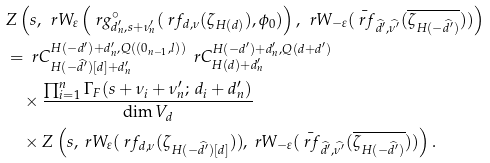<formula> <loc_0><loc_0><loc_500><loc_500>& Z \left ( s , \, \ r W _ { \varepsilon } \left ( \ r g ^ { \circ } _ { d _ { n } ^ { \prime } , s + \nu _ { n } ^ { \prime } } ( \ r f _ { d , \nu } ( \zeta _ { H ( d ) } ) , \phi _ { 0 } ) \right ) , \, \ r W _ { - \varepsilon } ( \bar { \ r f } _ { \widehat { d ^ { \prime } } , \widehat { \nu ^ { \prime } } } ( \overline { \zeta _ { H ( - \widehat { d ^ { \prime } } ) } } ) ) \right ) \\ & = { \ r C ^ { H ( - d ^ { \prime } ) + d _ { n } ^ { \prime } , Q ( ( 0 _ { n - 1 } , l ) ) } _ { H ( - \widehat { d ^ { \prime } } ) [ d ] + d _ { n } ^ { \prime } } } \, \ r C ^ { H ( - d ^ { \prime } ) + d _ { n } ^ { \prime } , Q ( d + d ^ { \prime } ) } _ { H ( d ) + d _ { n } ^ { \prime } } \\ & \quad \times \frac { \prod _ { i = 1 } ^ { n } \Gamma _ { F } ( s + \nu _ { i } + \nu _ { n } ^ { \prime } ; \, d _ { i } + d _ { n } ^ { \prime } ) } { \dim V _ { d } } \\ & \quad \times Z \left ( s , \ r W _ { \varepsilon } ( \ r f _ { d , \nu } ( \zeta _ { H ( - \widehat { d ^ { \prime } } ) [ d ] } ) ) , \ r W _ { - \varepsilon } ( \bar { \ r f } _ { \widehat { d ^ { \prime } } , \widehat { \nu ^ { \prime } } } ( \overline { \zeta _ { H ( - \widehat { d ^ { \prime } } ) } } ) ) \right ) .</formula> 